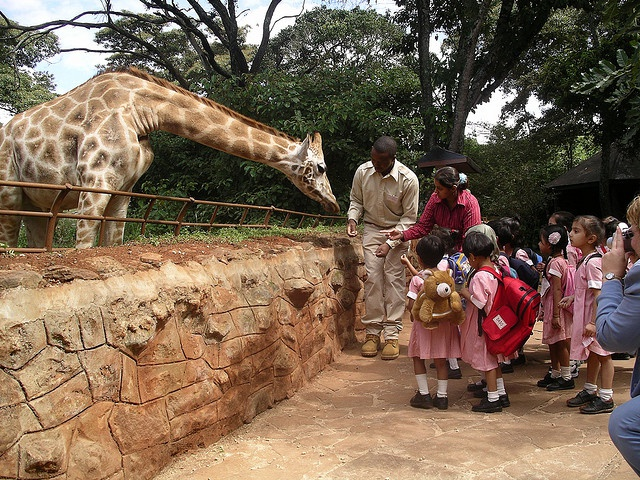Describe the objects in this image and their specific colors. I can see giraffe in lavender, tan, gray, and maroon tones, people in lavender, gray, and maroon tones, people in lavender, maroon, brown, and black tones, people in lavender, gray, and black tones, and people in lavender, brown, maroon, and black tones in this image. 